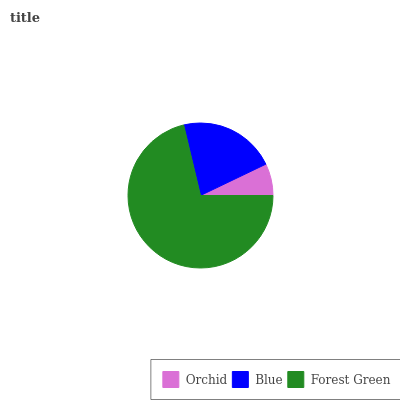Is Orchid the minimum?
Answer yes or no. Yes. Is Forest Green the maximum?
Answer yes or no. Yes. Is Blue the minimum?
Answer yes or no. No. Is Blue the maximum?
Answer yes or no. No. Is Blue greater than Orchid?
Answer yes or no. Yes. Is Orchid less than Blue?
Answer yes or no. Yes. Is Orchid greater than Blue?
Answer yes or no. No. Is Blue less than Orchid?
Answer yes or no. No. Is Blue the high median?
Answer yes or no. Yes. Is Blue the low median?
Answer yes or no. Yes. Is Orchid the high median?
Answer yes or no. No. Is Forest Green the low median?
Answer yes or no. No. 